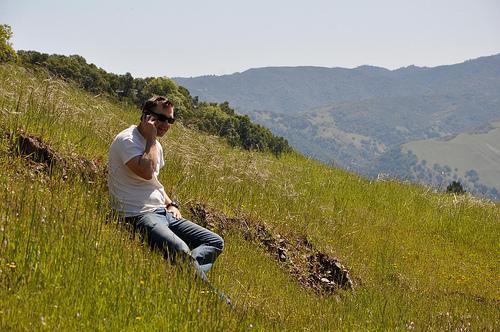How many people are there?
Give a very brief answer. 1. 